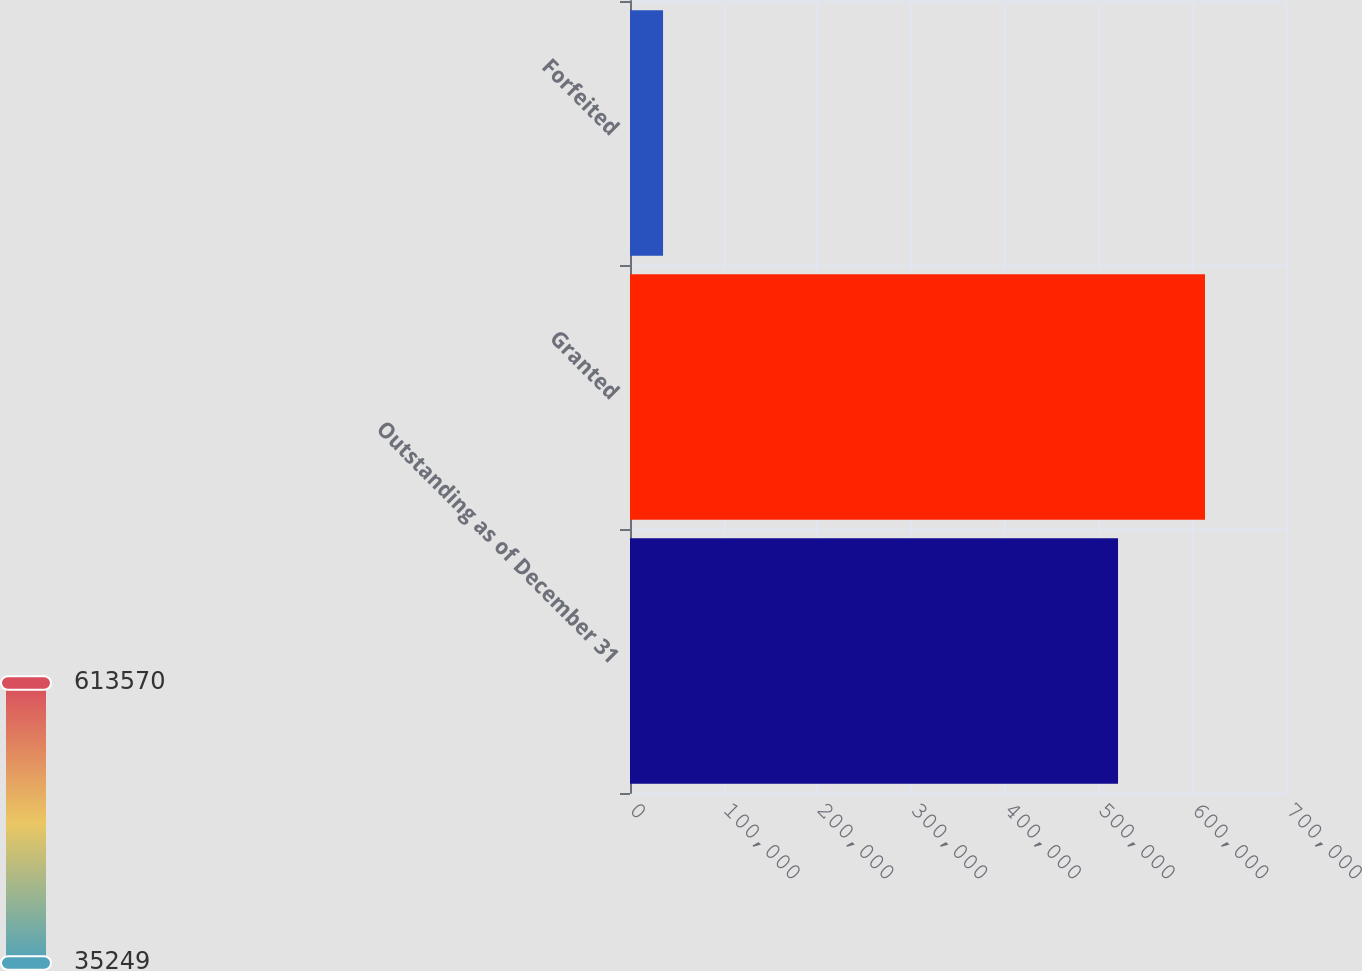Convert chart. <chart><loc_0><loc_0><loc_500><loc_500><bar_chart><fcel>Outstanding as of December 31<fcel>Granted<fcel>Forfeited<nl><fcel>520762<fcel>613570<fcel>35249<nl></chart> 